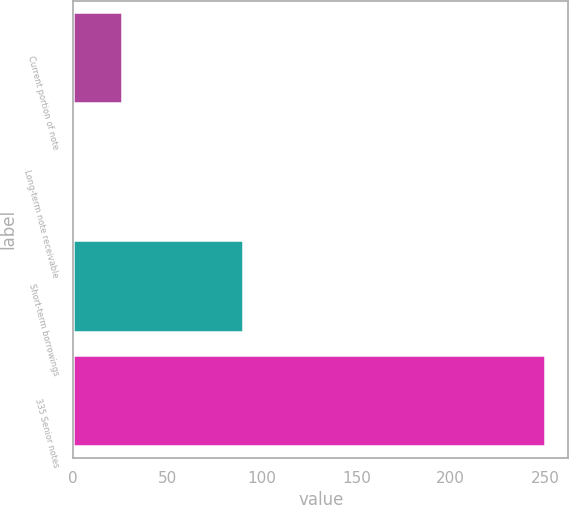<chart> <loc_0><loc_0><loc_500><loc_500><bar_chart><fcel>Current portion of note<fcel>Long-term note receivable<fcel>Short-term borrowings<fcel>335 Senior notes<nl><fcel>25.69<fcel>0.8<fcel>90<fcel>249.7<nl></chart> 